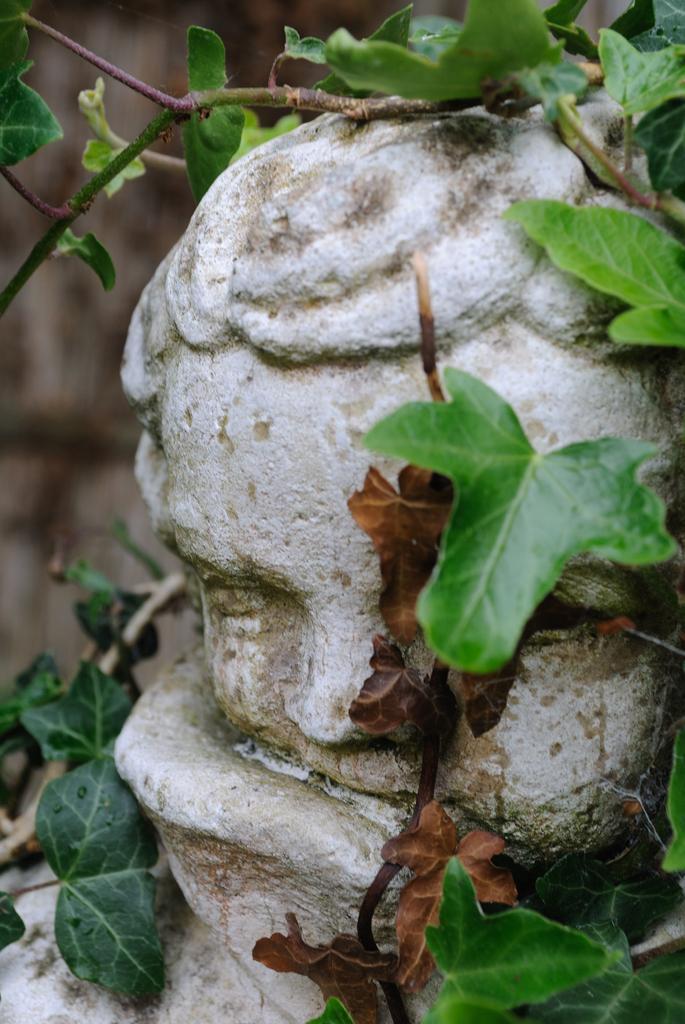Please provide a concise description of this image. In the image there is a sculpture and on the sculpture there are branches and leaves. 